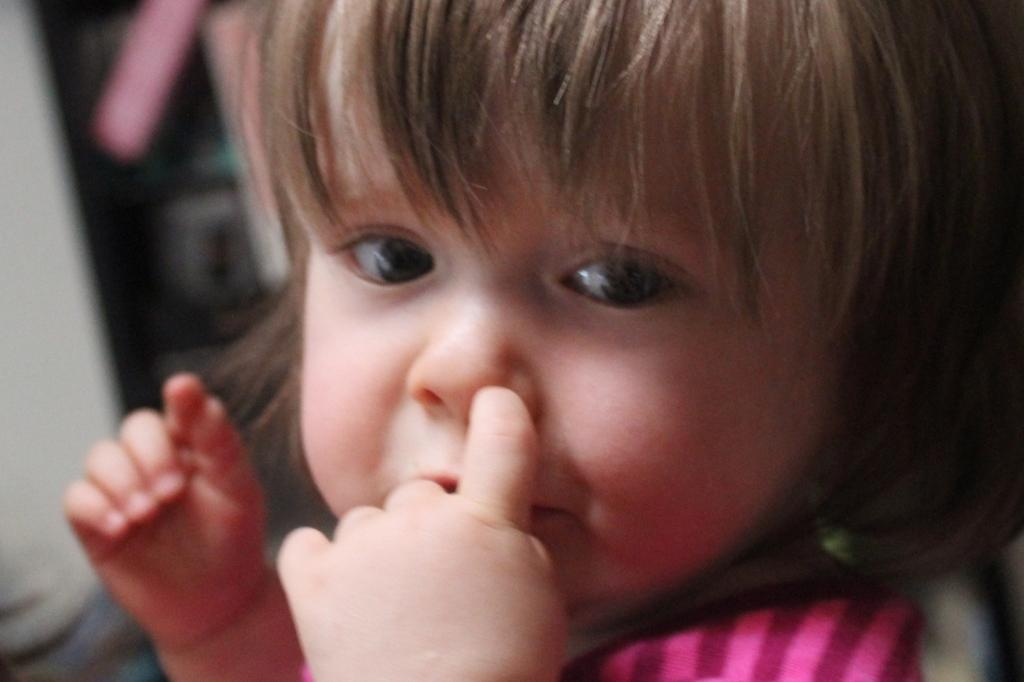Who is the main subject in the image? There is a girl in the image. What can be observed about the background of the image? The background of the image is blurred. What type of collar is the girl wearing in the image? There is no collar visible in the image, as the girl is not wearing any clothing or accessories that would have a collar. 